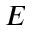<formula> <loc_0><loc_0><loc_500><loc_500>E</formula> 